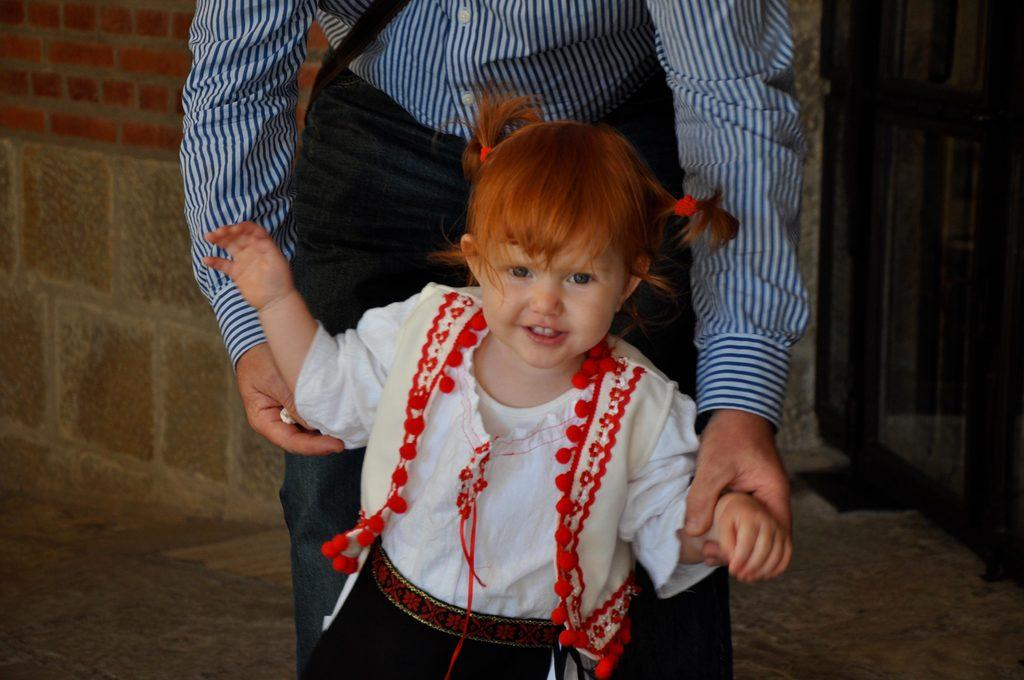What is the main subject of the image? The main subject of the image is a group of persons standing on the ground. Can you describe the attire of one of the kids in the group? One kid is wearing a white dress. What can be seen in the background of the image? There is a door visible in the background. What type of horn can be seen on the banana in the image? There is no banana or horn present in the image. 